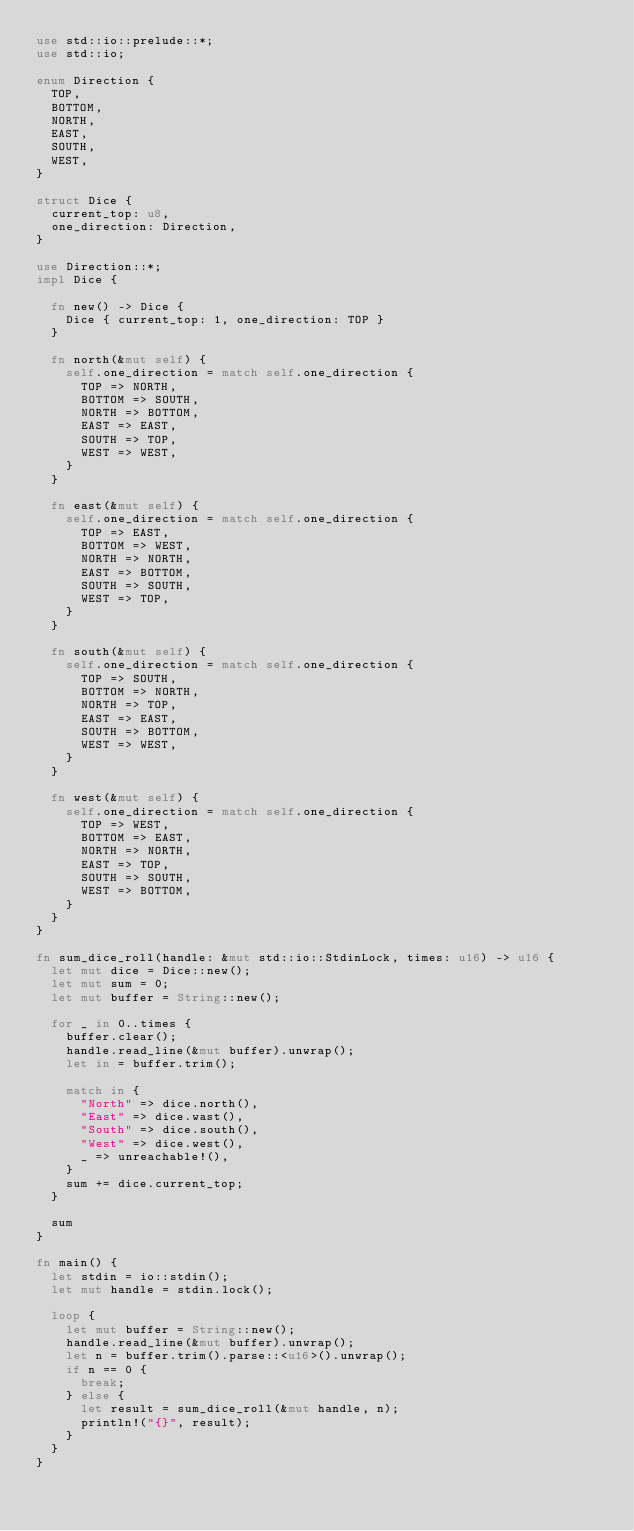<code> <loc_0><loc_0><loc_500><loc_500><_Rust_>use std::io::prelude::*;
use std::io;

enum Direction {
  TOP,
  BOTTOM,
  NORTH,
  EAST,
  SOUTH,
  WEST,
}

struct Dice {
  current_top: u8,
  one_direction: Direction,
}

use Direction::*;
impl Dice {

  fn new() -> Dice {
    Dice { current_top: 1, one_direction: TOP }
  }

  fn north(&mut self) {
    self.one_direction = match self.one_direction {
      TOP => NORTH,
      BOTTOM => SOUTH,
      NORTH => BOTTOM,
      EAST => EAST,
      SOUTH => TOP,
      WEST => WEST,
    }
  }
  
  fn east(&mut self) {
    self.one_direction = match self.one_direction {
      TOP => EAST,
      BOTTOM => WEST,
      NORTH => NORTH,
      EAST => BOTTOM,
      SOUTH => SOUTH,
      WEST => TOP,
    }
  }

  fn south(&mut self) {
    self.one_direction = match self.one_direction {
      TOP => SOUTH,
      BOTTOM => NORTH,
      NORTH => TOP,
      EAST => EAST,
      SOUTH => BOTTOM,
      WEST => WEST,
    }
  }
  
  fn west(&mut self) {
    self.one_direction = match self.one_direction {
      TOP => WEST,
      BOTTOM => EAST,
      NORTH => NORTH,
      EAST => TOP,
      SOUTH => SOUTH,
      WEST => BOTTOM,
    }
  }
}

fn sum_dice_roll(handle: &mut std::io::StdinLock, times: u16) -> u16 {
  let mut dice = Dice::new();
  let mut sum = 0;
  let mut buffer = String::new();

  for _ in 0..times {
    buffer.clear();
    handle.read_line(&mut buffer).unwrap();
    let in = buffer.trim();

    match in {
      "North" => dice.north(),
      "East" => dice.wast(),
      "South" => dice.south(),
      "West" => dice.west(),
      _ => unreachable!(),
    }
    sum += dice.current_top;
  }

  sum
}

fn main() {
  let stdin = io::stdin();
  let mut handle = stdin.lock();
  
  loop {
    let mut buffer = String::new();
    handle.read_line(&mut buffer).unwrap();
    let n = buffer.trim().parse::<u16>().unwrap();
    if n == 0 {
      break;
    } else {
      let result = sum_dice_roll(&mut handle, n);
      println!("{}", result);
    }
  }
}</code> 